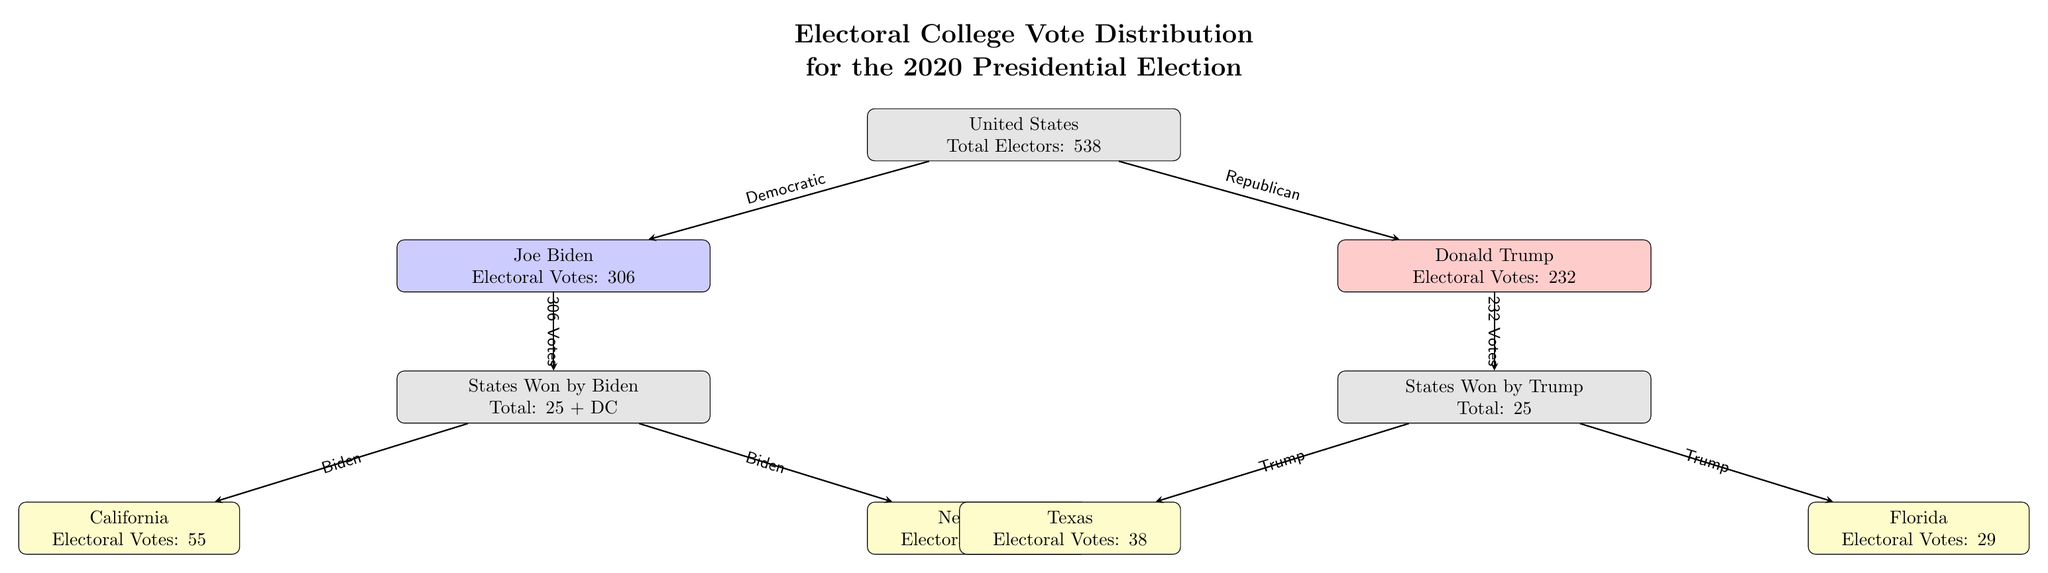What is the total number of electoral votes in the diagram? The diagram states that the total electors for the United States is 538, which is explicitly mentioned in the main node labeled "United States."
Answer: 538 How many electoral votes did Joe Biden receive? The node labeled "Joe Biden" indicates he received 306 electoral votes, which is displayed within that node.
Answer: 306 Which state has the highest number of electoral votes represented in the diagram? The diagram shows California listed under states won by Biden, indicating it has 55 electoral votes, which is the highest amount on the diagram.
Answer: California How many states did Joe Biden win? The node "States Won by Biden" indicates a total of 25 states plus Washington D.C., which can be directly inferred from the label.
Answer: 25 + DC What party did Donald Trump represent? The diagram indicates that the node for Donald Trump is connected with an arrow labeled "Republican," which signifies his party affiliation.
Answer: Republican How many electoral votes does Texas have? The node for Texas in the diagram indicates it has 38 electoral votes, which is clearly stated in the respective node.
Answer: 38 Which candidate received more electoral votes? By comparing the values in the nodes for Joe Biden and Donald Trump, Biden is shown with 306 electoral votes while Trump has 232, making it clear that Biden received more.
Answer: Joe Biden What is the difference in electoral votes between Biden and Trump? To find the difference, subtract Trump's electoral votes (232) from Biden's (306): 306 - 232 = 74, which is calculated from the values shown in their respective nodes.
Answer: 74 How many states did Donald Trump win? The node labeled "States Won by Trump" states a total of 25 states, which is directly indicated in that node.
Answer: 25 